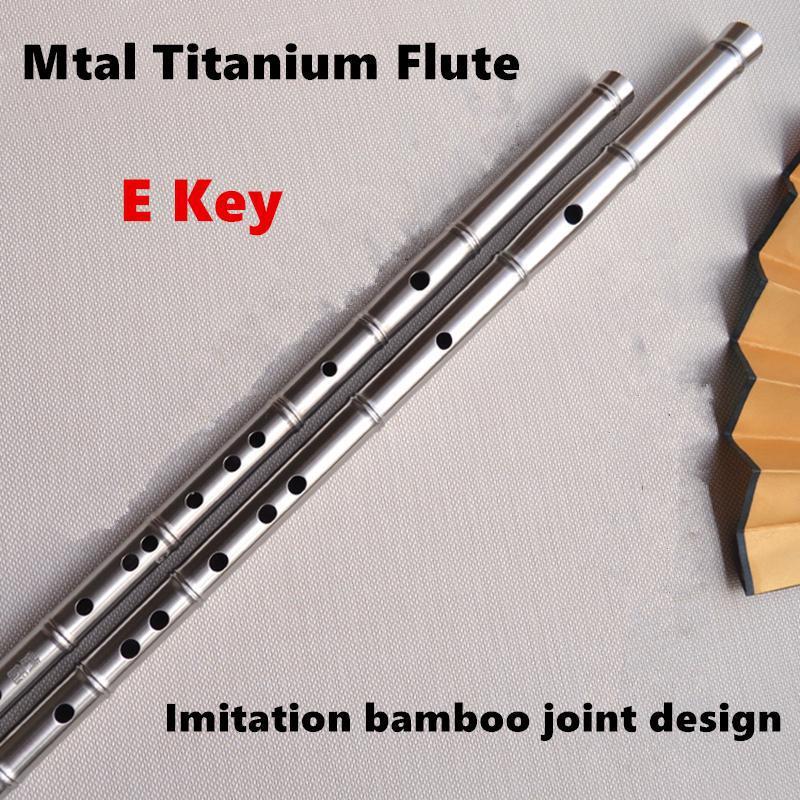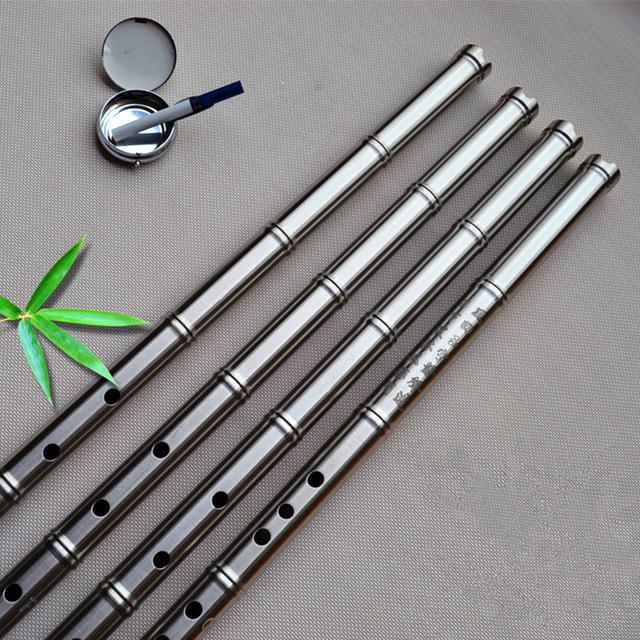The first image is the image on the left, the second image is the image on the right. For the images shown, is this caption "Three instruments lie in a row in one of the images." true? Answer yes or no. No. The first image is the image on the left, the second image is the image on the right. Assess this claim about the two images: "There are exactly five objects.". Correct or not? Answer yes or no. No. 